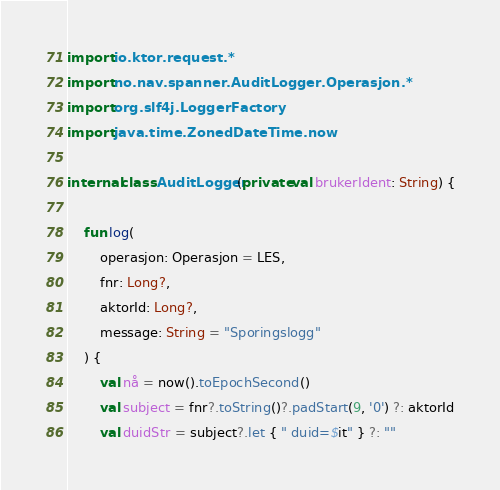<code> <loc_0><loc_0><loc_500><loc_500><_Kotlin_>import io.ktor.request.*
import no.nav.spanner.AuditLogger.Operasjon.*
import org.slf4j.LoggerFactory
import java.time.ZonedDateTime.now

internal class AuditLogger(private val brukerIdent: String) {

    fun log(
        operasjon: Operasjon = LES,
        fnr: Long?,
        aktorId: Long?,
        message: String = "Sporingslogg"
    ) {
        val nå = now().toEpochSecond()
        val subject = fnr?.toString()?.padStart(9, '0') ?: aktorId
        val duidStr = subject?.let { " duid=$it" } ?: ""</code> 